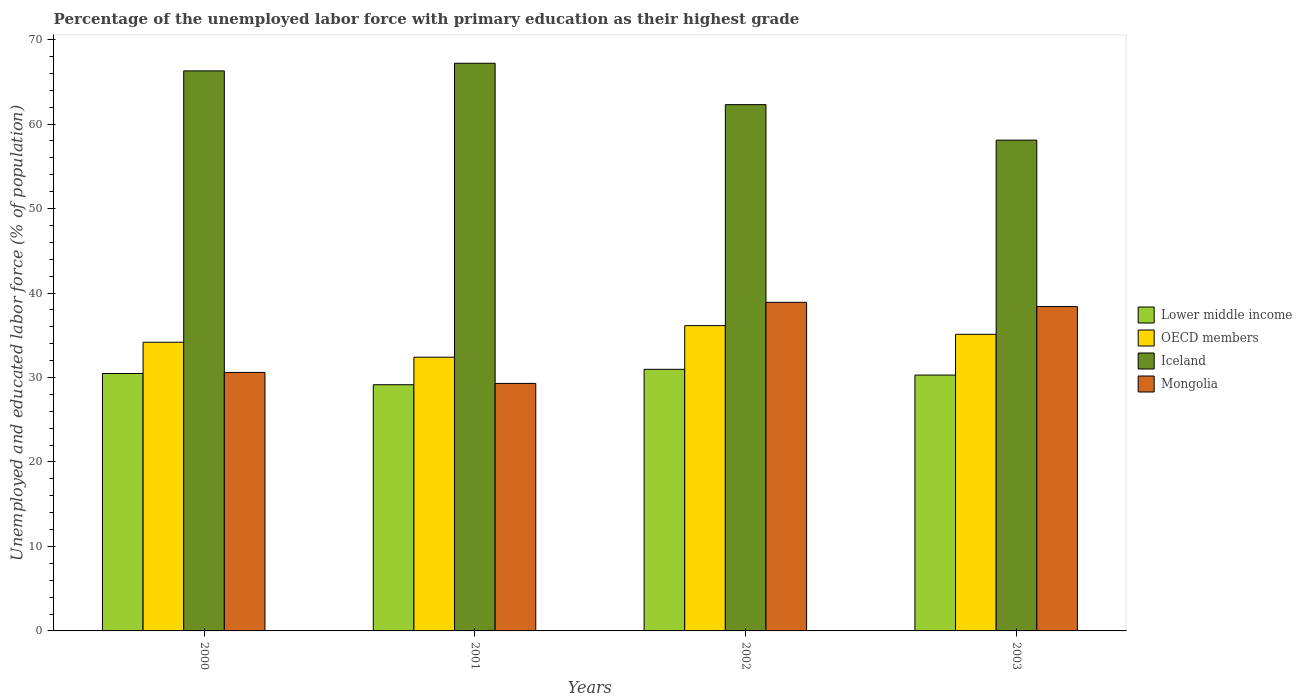Are the number of bars on each tick of the X-axis equal?
Provide a succinct answer. Yes. What is the label of the 2nd group of bars from the left?
Offer a terse response. 2001. In how many cases, is the number of bars for a given year not equal to the number of legend labels?
Your answer should be very brief. 0. What is the percentage of the unemployed labor force with primary education in Mongolia in 2002?
Offer a very short reply. 38.9. Across all years, what is the maximum percentage of the unemployed labor force with primary education in Iceland?
Provide a succinct answer. 67.2. Across all years, what is the minimum percentage of the unemployed labor force with primary education in Iceland?
Provide a short and direct response. 58.1. In which year was the percentage of the unemployed labor force with primary education in Iceland maximum?
Your answer should be compact. 2001. In which year was the percentage of the unemployed labor force with primary education in Iceland minimum?
Keep it short and to the point. 2003. What is the total percentage of the unemployed labor force with primary education in Iceland in the graph?
Offer a very short reply. 253.9. What is the difference between the percentage of the unemployed labor force with primary education in Lower middle income in 2000 and that in 2003?
Your answer should be compact. 0.18. What is the difference between the percentage of the unemployed labor force with primary education in Iceland in 2003 and the percentage of the unemployed labor force with primary education in Mongolia in 2002?
Your response must be concise. 19.2. What is the average percentage of the unemployed labor force with primary education in Mongolia per year?
Keep it short and to the point. 34.3. In the year 2002, what is the difference between the percentage of the unemployed labor force with primary education in Mongolia and percentage of the unemployed labor force with primary education in Lower middle income?
Offer a terse response. 7.93. What is the ratio of the percentage of the unemployed labor force with primary education in OECD members in 2000 to that in 2001?
Offer a terse response. 1.05. What is the difference between the highest and the second highest percentage of the unemployed labor force with primary education in Lower middle income?
Keep it short and to the point. 0.5. What is the difference between the highest and the lowest percentage of the unemployed labor force with primary education in Lower middle income?
Provide a succinct answer. 1.83. In how many years, is the percentage of the unemployed labor force with primary education in Lower middle income greater than the average percentage of the unemployed labor force with primary education in Lower middle income taken over all years?
Your answer should be very brief. 3. Is the sum of the percentage of the unemployed labor force with primary education in Mongolia in 2001 and 2002 greater than the maximum percentage of the unemployed labor force with primary education in OECD members across all years?
Make the answer very short. Yes. What does the 1st bar from the left in 2003 represents?
Your answer should be compact. Lower middle income. What does the 4th bar from the right in 2000 represents?
Give a very brief answer. Lower middle income. Is it the case that in every year, the sum of the percentage of the unemployed labor force with primary education in Mongolia and percentage of the unemployed labor force with primary education in OECD members is greater than the percentage of the unemployed labor force with primary education in Iceland?
Offer a very short reply. No. How many bars are there?
Offer a terse response. 16. How many years are there in the graph?
Your answer should be compact. 4. Does the graph contain any zero values?
Ensure brevity in your answer.  No. Does the graph contain grids?
Offer a terse response. No. How many legend labels are there?
Provide a succinct answer. 4. How are the legend labels stacked?
Your answer should be very brief. Vertical. What is the title of the graph?
Provide a succinct answer. Percentage of the unemployed labor force with primary education as their highest grade. Does "Kuwait" appear as one of the legend labels in the graph?
Provide a succinct answer. No. What is the label or title of the Y-axis?
Provide a succinct answer. Unemployed and educated labor force (% of population). What is the Unemployed and educated labor force (% of population) in Lower middle income in 2000?
Your answer should be very brief. 30.47. What is the Unemployed and educated labor force (% of population) in OECD members in 2000?
Your response must be concise. 34.17. What is the Unemployed and educated labor force (% of population) of Iceland in 2000?
Keep it short and to the point. 66.3. What is the Unemployed and educated labor force (% of population) in Mongolia in 2000?
Ensure brevity in your answer.  30.6. What is the Unemployed and educated labor force (% of population) in Lower middle income in 2001?
Offer a terse response. 29.14. What is the Unemployed and educated labor force (% of population) of OECD members in 2001?
Ensure brevity in your answer.  32.4. What is the Unemployed and educated labor force (% of population) of Iceland in 2001?
Keep it short and to the point. 67.2. What is the Unemployed and educated labor force (% of population) in Mongolia in 2001?
Make the answer very short. 29.3. What is the Unemployed and educated labor force (% of population) in Lower middle income in 2002?
Your answer should be very brief. 30.97. What is the Unemployed and educated labor force (% of population) in OECD members in 2002?
Keep it short and to the point. 36.14. What is the Unemployed and educated labor force (% of population) in Iceland in 2002?
Offer a very short reply. 62.3. What is the Unemployed and educated labor force (% of population) of Mongolia in 2002?
Ensure brevity in your answer.  38.9. What is the Unemployed and educated labor force (% of population) of Lower middle income in 2003?
Give a very brief answer. 30.29. What is the Unemployed and educated labor force (% of population) of OECD members in 2003?
Keep it short and to the point. 35.11. What is the Unemployed and educated labor force (% of population) of Iceland in 2003?
Provide a succinct answer. 58.1. What is the Unemployed and educated labor force (% of population) in Mongolia in 2003?
Provide a short and direct response. 38.4. Across all years, what is the maximum Unemployed and educated labor force (% of population) of Lower middle income?
Ensure brevity in your answer.  30.97. Across all years, what is the maximum Unemployed and educated labor force (% of population) of OECD members?
Provide a succinct answer. 36.14. Across all years, what is the maximum Unemployed and educated labor force (% of population) of Iceland?
Give a very brief answer. 67.2. Across all years, what is the maximum Unemployed and educated labor force (% of population) in Mongolia?
Give a very brief answer. 38.9. Across all years, what is the minimum Unemployed and educated labor force (% of population) in Lower middle income?
Keep it short and to the point. 29.14. Across all years, what is the minimum Unemployed and educated labor force (% of population) of OECD members?
Your answer should be compact. 32.4. Across all years, what is the minimum Unemployed and educated labor force (% of population) in Iceland?
Provide a succinct answer. 58.1. Across all years, what is the minimum Unemployed and educated labor force (% of population) of Mongolia?
Your answer should be very brief. 29.3. What is the total Unemployed and educated labor force (% of population) in Lower middle income in the graph?
Your answer should be compact. 120.87. What is the total Unemployed and educated labor force (% of population) of OECD members in the graph?
Your answer should be compact. 137.83. What is the total Unemployed and educated labor force (% of population) of Iceland in the graph?
Your answer should be compact. 253.9. What is the total Unemployed and educated labor force (% of population) of Mongolia in the graph?
Your response must be concise. 137.2. What is the difference between the Unemployed and educated labor force (% of population) of Lower middle income in 2000 and that in 2001?
Give a very brief answer. 1.33. What is the difference between the Unemployed and educated labor force (% of population) of OECD members in 2000 and that in 2001?
Your answer should be very brief. 1.77. What is the difference between the Unemployed and educated labor force (% of population) in Lower middle income in 2000 and that in 2002?
Your response must be concise. -0.5. What is the difference between the Unemployed and educated labor force (% of population) in OECD members in 2000 and that in 2002?
Provide a short and direct response. -1.97. What is the difference between the Unemployed and educated labor force (% of population) of Iceland in 2000 and that in 2002?
Provide a succinct answer. 4. What is the difference between the Unemployed and educated labor force (% of population) in Lower middle income in 2000 and that in 2003?
Your answer should be very brief. 0.18. What is the difference between the Unemployed and educated labor force (% of population) of OECD members in 2000 and that in 2003?
Your answer should be compact. -0.94. What is the difference between the Unemployed and educated labor force (% of population) of Mongolia in 2000 and that in 2003?
Offer a terse response. -7.8. What is the difference between the Unemployed and educated labor force (% of population) in Lower middle income in 2001 and that in 2002?
Provide a succinct answer. -1.83. What is the difference between the Unemployed and educated labor force (% of population) in OECD members in 2001 and that in 2002?
Provide a succinct answer. -3.74. What is the difference between the Unemployed and educated labor force (% of population) of Lower middle income in 2001 and that in 2003?
Provide a succinct answer. -1.15. What is the difference between the Unemployed and educated labor force (% of population) in OECD members in 2001 and that in 2003?
Offer a terse response. -2.71. What is the difference between the Unemployed and educated labor force (% of population) in Iceland in 2001 and that in 2003?
Give a very brief answer. 9.1. What is the difference between the Unemployed and educated labor force (% of population) in Lower middle income in 2002 and that in 2003?
Your answer should be compact. 0.68. What is the difference between the Unemployed and educated labor force (% of population) in OECD members in 2002 and that in 2003?
Provide a short and direct response. 1.03. What is the difference between the Unemployed and educated labor force (% of population) in Lower middle income in 2000 and the Unemployed and educated labor force (% of population) in OECD members in 2001?
Offer a terse response. -1.93. What is the difference between the Unemployed and educated labor force (% of population) in Lower middle income in 2000 and the Unemployed and educated labor force (% of population) in Iceland in 2001?
Your answer should be very brief. -36.73. What is the difference between the Unemployed and educated labor force (% of population) of Lower middle income in 2000 and the Unemployed and educated labor force (% of population) of Mongolia in 2001?
Your answer should be very brief. 1.17. What is the difference between the Unemployed and educated labor force (% of population) in OECD members in 2000 and the Unemployed and educated labor force (% of population) in Iceland in 2001?
Provide a succinct answer. -33.03. What is the difference between the Unemployed and educated labor force (% of population) in OECD members in 2000 and the Unemployed and educated labor force (% of population) in Mongolia in 2001?
Your answer should be compact. 4.87. What is the difference between the Unemployed and educated labor force (% of population) in Lower middle income in 2000 and the Unemployed and educated labor force (% of population) in OECD members in 2002?
Provide a succinct answer. -5.67. What is the difference between the Unemployed and educated labor force (% of population) of Lower middle income in 2000 and the Unemployed and educated labor force (% of population) of Iceland in 2002?
Keep it short and to the point. -31.83. What is the difference between the Unemployed and educated labor force (% of population) in Lower middle income in 2000 and the Unemployed and educated labor force (% of population) in Mongolia in 2002?
Your answer should be very brief. -8.43. What is the difference between the Unemployed and educated labor force (% of population) in OECD members in 2000 and the Unemployed and educated labor force (% of population) in Iceland in 2002?
Your answer should be compact. -28.13. What is the difference between the Unemployed and educated labor force (% of population) of OECD members in 2000 and the Unemployed and educated labor force (% of population) of Mongolia in 2002?
Keep it short and to the point. -4.73. What is the difference between the Unemployed and educated labor force (% of population) of Iceland in 2000 and the Unemployed and educated labor force (% of population) of Mongolia in 2002?
Make the answer very short. 27.4. What is the difference between the Unemployed and educated labor force (% of population) in Lower middle income in 2000 and the Unemployed and educated labor force (% of population) in OECD members in 2003?
Your answer should be compact. -4.64. What is the difference between the Unemployed and educated labor force (% of population) in Lower middle income in 2000 and the Unemployed and educated labor force (% of population) in Iceland in 2003?
Your answer should be compact. -27.63. What is the difference between the Unemployed and educated labor force (% of population) in Lower middle income in 2000 and the Unemployed and educated labor force (% of population) in Mongolia in 2003?
Your answer should be compact. -7.93. What is the difference between the Unemployed and educated labor force (% of population) of OECD members in 2000 and the Unemployed and educated labor force (% of population) of Iceland in 2003?
Keep it short and to the point. -23.93. What is the difference between the Unemployed and educated labor force (% of population) of OECD members in 2000 and the Unemployed and educated labor force (% of population) of Mongolia in 2003?
Ensure brevity in your answer.  -4.23. What is the difference between the Unemployed and educated labor force (% of population) in Iceland in 2000 and the Unemployed and educated labor force (% of population) in Mongolia in 2003?
Give a very brief answer. 27.9. What is the difference between the Unemployed and educated labor force (% of population) in Lower middle income in 2001 and the Unemployed and educated labor force (% of population) in OECD members in 2002?
Keep it short and to the point. -7. What is the difference between the Unemployed and educated labor force (% of population) of Lower middle income in 2001 and the Unemployed and educated labor force (% of population) of Iceland in 2002?
Give a very brief answer. -33.16. What is the difference between the Unemployed and educated labor force (% of population) of Lower middle income in 2001 and the Unemployed and educated labor force (% of population) of Mongolia in 2002?
Your answer should be compact. -9.76. What is the difference between the Unemployed and educated labor force (% of population) in OECD members in 2001 and the Unemployed and educated labor force (% of population) in Iceland in 2002?
Your answer should be compact. -29.9. What is the difference between the Unemployed and educated labor force (% of population) in OECD members in 2001 and the Unemployed and educated labor force (% of population) in Mongolia in 2002?
Your response must be concise. -6.5. What is the difference between the Unemployed and educated labor force (% of population) in Iceland in 2001 and the Unemployed and educated labor force (% of population) in Mongolia in 2002?
Offer a very short reply. 28.3. What is the difference between the Unemployed and educated labor force (% of population) in Lower middle income in 2001 and the Unemployed and educated labor force (% of population) in OECD members in 2003?
Keep it short and to the point. -5.97. What is the difference between the Unemployed and educated labor force (% of population) in Lower middle income in 2001 and the Unemployed and educated labor force (% of population) in Iceland in 2003?
Your answer should be compact. -28.96. What is the difference between the Unemployed and educated labor force (% of population) of Lower middle income in 2001 and the Unemployed and educated labor force (% of population) of Mongolia in 2003?
Give a very brief answer. -9.26. What is the difference between the Unemployed and educated labor force (% of population) in OECD members in 2001 and the Unemployed and educated labor force (% of population) in Iceland in 2003?
Your answer should be compact. -25.7. What is the difference between the Unemployed and educated labor force (% of population) in OECD members in 2001 and the Unemployed and educated labor force (% of population) in Mongolia in 2003?
Provide a short and direct response. -6. What is the difference between the Unemployed and educated labor force (% of population) of Iceland in 2001 and the Unemployed and educated labor force (% of population) of Mongolia in 2003?
Ensure brevity in your answer.  28.8. What is the difference between the Unemployed and educated labor force (% of population) in Lower middle income in 2002 and the Unemployed and educated labor force (% of population) in OECD members in 2003?
Provide a succinct answer. -4.15. What is the difference between the Unemployed and educated labor force (% of population) of Lower middle income in 2002 and the Unemployed and educated labor force (% of population) of Iceland in 2003?
Your response must be concise. -27.13. What is the difference between the Unemployed and educated labor force (% of population) in Lower middle income in 2002 and the Unemployed and educated labor force (% of population) in Mongolia in 2003?
Offer a terse response. -7.43. What is the difference between the Unemployed and educated labor force (% of population) of OECD members in 2002 and the Unemployed and educated labor force (% of population) of Iceland in 2003?
Your answer should be compact. -21.96. What is the difference between the Unemployed and educated labor force (% of population) in OECD members in 2002 and the Unemployed and educated labor force (% of population) in Mongolia in 2003?
Give a very brief answer. -2.26. What is the difference between the Unemployed and educated labor force (% of population) of Iceland in 2002 and the Unemployed and educated labor force (% of population) of Mongolia in 2003?
Offer a terse response. 23.9. What is the average Unemployed and educated labor force (% of population) of Lower middle income per year?
Offer a very short reply. 30.22. What is the average Unemployed and educated labor force (% of population) in OECD members per year?
Give a very brief answer. 34.46. What is the average Unemployed and educated labor force (% of population) in Iceland per year?
Provide a short and direct response. 63.48. What is the average Unemployed and educated labor force (% of population) of Mongolia per year?
Your answer should be compact. 34.3. In the year 2000, what is the difference between the Unemployed and educated labor force (% of population) of Lower middle income and Unemployed and educated labor force (% of population) of OECD members?
Offer a terse response. -3.7. In the year 2000, what is the difference between the Unemployed and educated labor force (% of population) in Lower middle income and Unemployed and educated labor force (% of population) in Iceland?
Make the answer very short. -35.83. In the year 2000, what is the difference between the Unemployed and educated labor force (% of population) in Lower middle income and Unemployed and educated labor force (% of population) in Mongolia?
Offer a very short reply. -0.13. In the year 2000, what is the difference between the Unemployed and educated labor force (% of population) of OECD members and Unemployed and educated labor force (% of population) of Iceland?
Offer a terse response. -32.13. In the year 2000, what is the difference between the Unemployed and educated labor force (% of population) of OECD members and Unemployed and educated labor force (% of population) of Mongolia?
Offer a terse response. 3.57. In the year 2000, what is the difference between the Unemployed and educated labor force (% of population) of Iceland and Unemployed and educated labor force (% of population) of Mongolia?
Offer a very short reply. 35.7. In the year 2001, what is the difference between the Unemployed and educated labor force (% of population) of Lower middle income and Unemployed and educated labor force (% of population) of OECD members?
Ensure brevity in your answer.  -3.26. In the year 2001, what is the difference between the Unemployed and educated labor force (% of population) of Lower middle income and Unemployed and educated labor force (% of population) of Iceland?
Your answer should be very brief. -38.06. In the year 2001, what is the difference between the Unemployed and educated labor force (% of population) of Lower middle income and Unemployed and educated labor force (% of population) of Mongolia?
Give a very brief answer. -0.16. In the year 2001, what is the difference between the Unemployed and educated labor force (% of population) of OECD members and Unemployed and educated labor force (% of population) of Iceland?
Offer a very short reply. -34.8. In the year 2001, what is the difference between the Unemployed and educated labor force (% of population) of OECD members and Unemployed and educated labor force (% of population) of Mongolia?
Offer a terse response. 3.1. In the year 2001, what is the difference between the Unemployed and educated labor force (% of population) in Iceland and Unemployed and educated labor force (% of population) in Mongolia?
Provide a succinct answer. 37.9. In the year 2002, what is the difference between the Unemployed and educated labor force (% of population) in Lower middle income and Unemployed and educated labor force (% of population) in OECD members?
Keep it short and to the point. -5.17. In the year 2002, what is the difference between the Unemployed and educated labor force (% of population) of Lower middle income and Unemployed and educated labor force (% of population) of Iceland?
Keep it short and to the point. -31.33. In the year 2002, what is the difference between the Unemployed and educated labor force (% of population) of Lower middle income and Unemployed and educated labor force (% of population) of Mongolia?
Your answer should be compact. -7.93. In the year 2002, what is the difference between the Unemployed and educated labor force (% of population) of OECD members and Unemployed and educated labor force (% of population) of Iceland?
Keep it short and to the point. -26.16. In the year 2002, what is the difference between the Unemployed and educated labor force (% of population) in OECD members and Unemployed and educated labor force (% of population) in Mongolia?
Your answer should be very brief. -2.76. In the year 2002, what is the difference between the Unemployed and educated labor force (% of population) of Iceland and Unemployed and educated labor force (% of population) of Mongolia?
Give a very brief answer. 23.4. In the year 2003, what is the difference between the Unemployed and educated labor force (% of population) in Lower middle income and Unemployed and educated labor force (% of population) in OECD members?
Offer a very short reply. -4.83. In the year 2003, what is the difference between the Unemployed and educated labor force (% of population) of Lower middle income and Unemployed and educated labor force (% of population) of Iceland?
Keep it short and to the point. -27.81. In the year 2003, what is the difference between the Unemployed and educated labor force (% of population) of Lower middle income and Unemployed and educated labor force (% of population) of Mongolia?
Give a very brief answer. -8.11. In the year 2003, what is the difference between the Unemployed and educated labor force (% of population) of OECD members and Unemployed and educated labor force (% of population) of Iceland?
Make the answer very short. -22.99. In the year 2003, what is the difference between the Unemployed and educated labor force (% of population) in OECD members and Unemployed and educated labor force (% of population) in Mongolia?
Your answer should be compact. -3.29. In the year 2003, what is the difference between the Unemployed and educated labor force (% of population) of Iceland and Unemployed and educated labor force (% of population) of Mongolia?
Give a very brief answer. 19.7. What is the ratio of the Unemployed and educated labor force (% of population) in Lower middle income in 2000 to that in 2001?
Your response must be concise. 1.05. What is the ratio of the Unemployed and educated labor force (% of population) in OECD members in 2000 to that in 2001?
Provide a succinct answer. 1.05. What is the ratio of the Unemployed and educated labor force (% of population) of Iceland in 2000 to that in 2001?
Offer a very short reply. 0.99. What is the ratio of the Unemployed and educated labor force (% of population) in Mongolia in 2000 to that in 2001?
Your answer should be very brief. 1.04. What is the ratio of the Unemployed and educated labor force (% of population) of Lower middle income in 2000 to that in 2002?
Your answer should be compact. 0.98. What is the ratio of the Unemployed and educated labor force (% of population) in OECD members in 2000 to that in 2002?
Provide a succinct answer. 0.95. What is the ratio of the Unemployed and educated labor force (% of population) in Iceland in 2000 to that in 2002?
Offer a very short reply. 1.06. What is the ratio of the Unemployed and educated labor force (% of population) of Mongolia in 2000 to that in 2002?
Offer a very short reply. 0.79. What is the ratio of the Unemployed and educated labor force (% of population) in OECD members in 2000 to that in 2003?
Ensure brevity in your answer.  0.97. What is the ratio of the Unemployed and educated labor force (% of population) in Iceland in 2000 to that in 2003?
Provide a succinct answer. 1.14. What is the ratio of the Unemployed and educated labor force (% of population) of Mongolia in 2000 to that in 2003?
Keep it short and to the point. 0.8. What is the ratio of the Unemployed and educated labor force (% of population) of Lower middle income in 2001 to that in 2002?
Provide a succinct answer. 0.94. What is the ratio of the Unemployed and educated labor force (% of population) in OECD members in 2001 to that in 2002?
Offer a terse response. 0.9. What is the ratio of the Unemployed and educated labor force (% of population) in Iceland in 2001 to that in 2002?
Offer a terse response. 1.08. What is the ratio of the Unemployed and educated labor force (% of population) in Mongolia in 2001 to that in 2002?
Provide a succinct answer. 0.75. What is the ratio of the Unemployed and educated labor force (% of population) in Lower middle income in 2001 to that in 2003?
Ensure brevity in your answer.  0.96. What is the ratio of the Unemployed and educated labor force (% of population) in OECD members in 2001 to that in 2003?
Your answer should be compact. 0.92. What is the ratio of the Unemployed and educated labor force (% of population) of Iceland in 2001 to that in 2003?
Ensure brevity in your answer.  1.16. What is the ratio of the Unemployed and educated labor force (% of population) in Mongolia in 2001 to that in 2003?
Keep it short and to the point. 0.76. What is the ratio of the Unemployed and educated labor force (% of population) in Lower middle income in 2002 to that in 2003?
Offer a terse response. 1.02. What is the ratio of the Unemployed and educated labor force (% of population) in OECD members in 2002 to that in 2003?
Give a very brief answer. 1.03. What is the ratio of the Unemployed and educated labor force (% of population) in Iceland in 2002 to that in 2003?
Your response must be concise. 1.07. What is the difference between the highest and the second highest Unemployed and educated labor force (% of population) of Lower middle income?
Your answer should be compact. 0.5. What is the difference between the highest and the second highest Unemployed and educated labor force (% of population) of OECD members?
Make the answer very short. 1.03. What is the difference between the highest and the second highest Unemployed and educated labor force (% of population) in Mongolia?
Provide a succinct answer. 0.5. What is the difference between the highest and the lowest Unemployed and educated labor force (% of population) in Lower middle income?
Provide a short and direct response. 1.83. What is the difference between the highest and the lowest Unemployed and educated labor force (% of population) in OECD members?
Keep it short and to the point. 3.74. What is the difference between the highest and the lowest Unemployed and educated labor force (% of population) of Iceland?
Provide a succinct answer. 9.1. What is the difference between the highest and the lowest Unemployed and educated labor force (% of population) of Mongolia?
Ensure brevity in your answer.  9.6. 